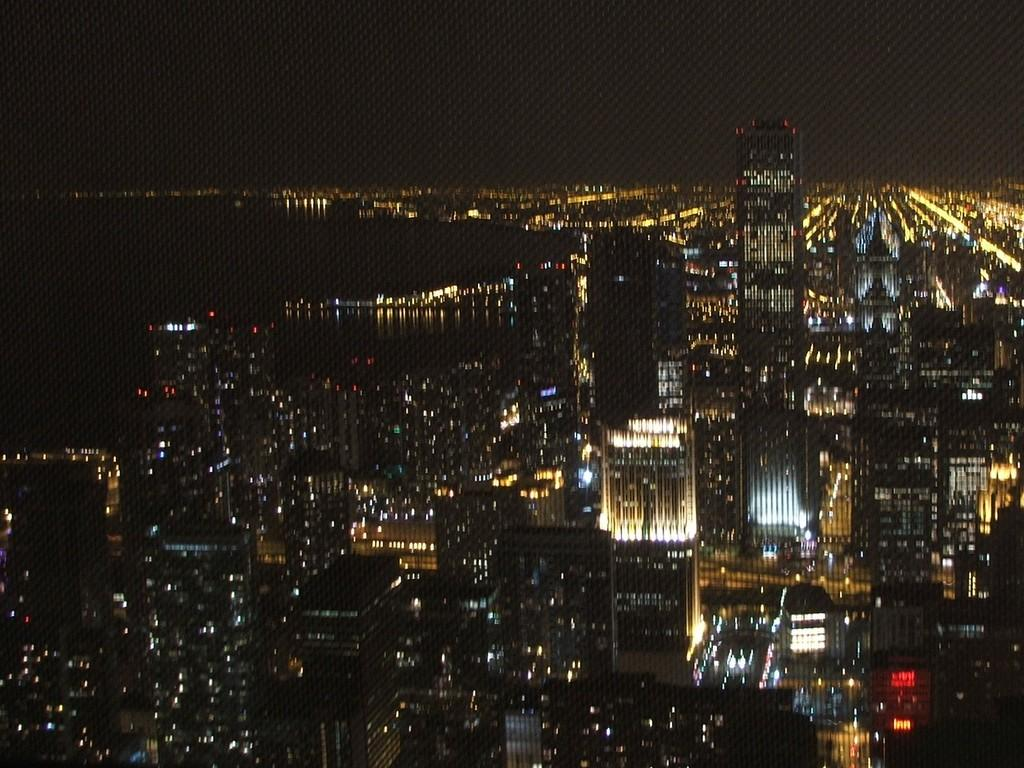What is the main subject of the image? The main subject of the image is many buildings. What natural feature can be seen on the left side of the image? There is a sea visible on the left side of the image. What is visible at the top of the image? The sky is visible at the top of the image. What type of baseball equipment can be seen in the image? There is no baseball equipment present in the image. What country is depicted in the image? The image does not depict a specific country; it shows buildings and a sea. What type of home is visible in the image? There is no home visible in the image; it features many buildings and a sea. 